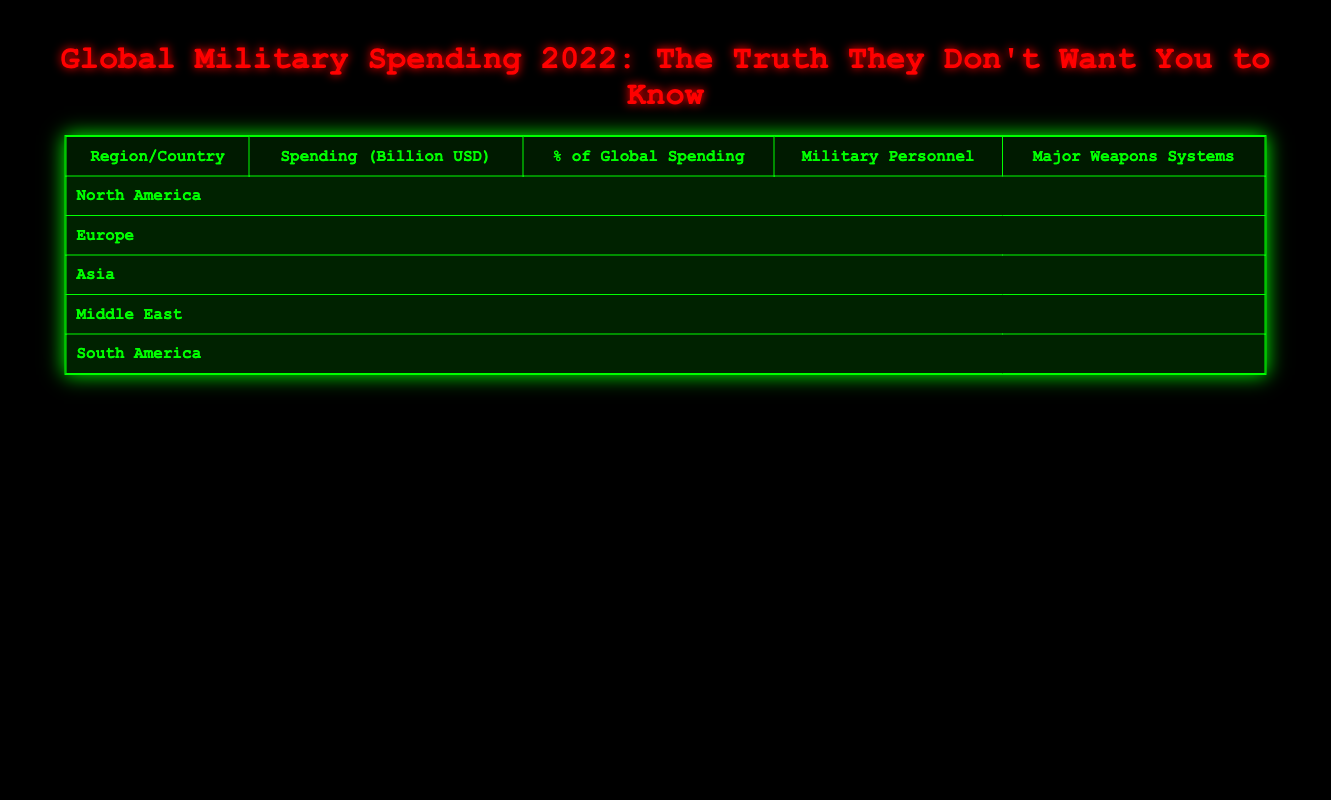What's the total military spending of North America? To find the total spending for North America, we add the spending for the United States (877 billion USD) and Canada (26 billion USD). The calculation is 877 + 26 = 903 billion USD.
Answer: 903 billion USD Which country has the highest percentage of global military spending? According to the table, the United States has the highest percentage of global military spending at 39%.
Answer: United States What is the median spending of the countries listed in Europe? The European countries listed are Russia (65 billion USD), United Kingdom (69 billion USD), and France (56 billion USD). To find the median, we list them in order: 56, 65, 69. The median is the middle value, which is 65 billion USD.
Answer: 65 billion USD Does Japan spend more than India on military? Japan's military spending is 49 billion USD, while India's spending is 76 billion USD. Therefore, Japan does not spend more than India.
Answer: No What is the total military personnel of all the countries in Asia? The countries listed in Asia are China (2,000,000), India (1,450,000), and Japan (240,000). To get the total, we add them: 2,000,000 + 1,450,000 + 240,000 = 3,690,000.
Answer: 3,690,000 Which region has the least spending by a single country? In South America, Brazil has the least spending at 31 billion USD, which is lower than any spending from countries in other regions.
Answer: South America What is the combined military spending of the Middle East countries? The countries in the Middle East are Saudi Arabia (81 billion USD) and Israel (24 billion USD). Adding these together gives 81 + 24 = 105 billion USD.
Answer: 105 billion USD Is the military spending of Canada greater than that of Israel? Canada has a military spending of 26 billion USD and Israel has 24 billion USD. Since 26 is greater than 24, Canada's spending is higher.
Answer: Yes How many military personnel does China have? According to the table, China has 2,000,000 military personnel. The data point is directly stated in the table.
Answer: 2,000,000 